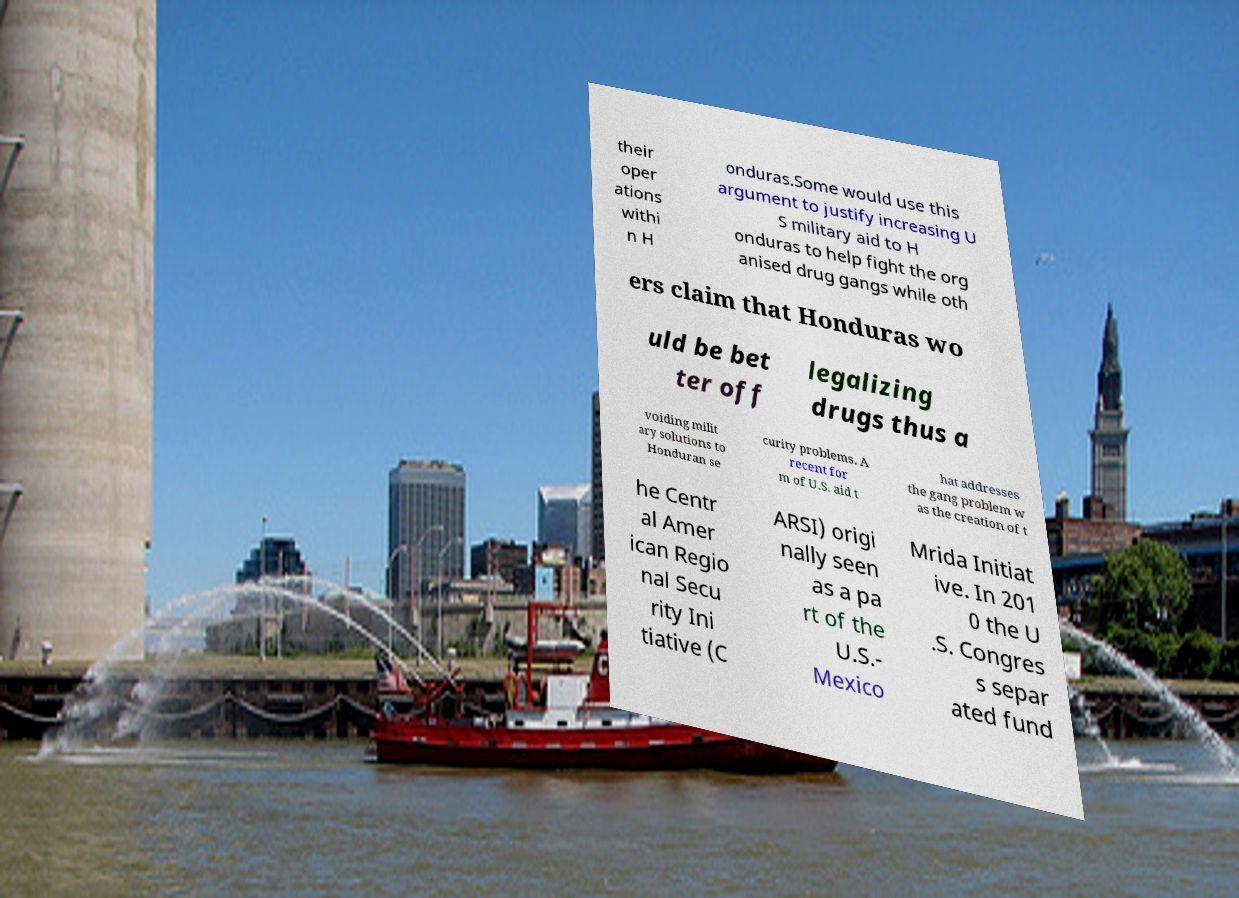Can you accurately transcribe the text from the provided image for me? their oper ations withi n H onduras.Some would use this argument to justify increasing U S military aid to H onduras to help fight the org anised drug gangs while oth ers claim that Honduras wo uld be bet ter off legalizing drugs thus a voiding milit ary solutions to Honduran se curity problems. A recent for m of U.S. aid t hat addresses the gang problem w as the creation of t he Centr al Amer ican Regio nal Secu rity Ini tiative (C ARSI) origi nally seen as a pa rt of the U.S.- Mexico Mrida Initiat ive. In 201 0 the U .S. Congres s separ ated fund 